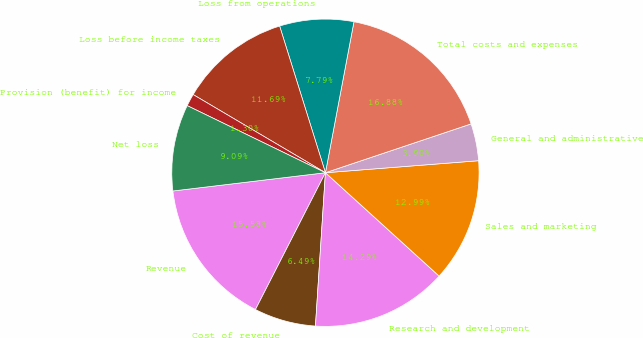Convert chart to OTSL. <chart><loc_0><loc_0><loc_500><loc_500><pie_chart><fcel>Revenue<fcel>Cost of revenue<fcel>Research and development<fcel>Sales and marketing<fcel>General and administrative<fcel>Total costs and expenses<fcel>Loss from operations<fcel>Loss before income taxes<fcel>Provision (benefit) for income<fcel>Net loss<nl><fcel>15.58%<fcel>6.49%<fcel>14.29%<fcel>12.99%<fcel>3.9%<fcel>16.88%<fcel>7.79%<fcel>11.69%<fcel>1.3%<fcel>9.09%<nl></chart> 